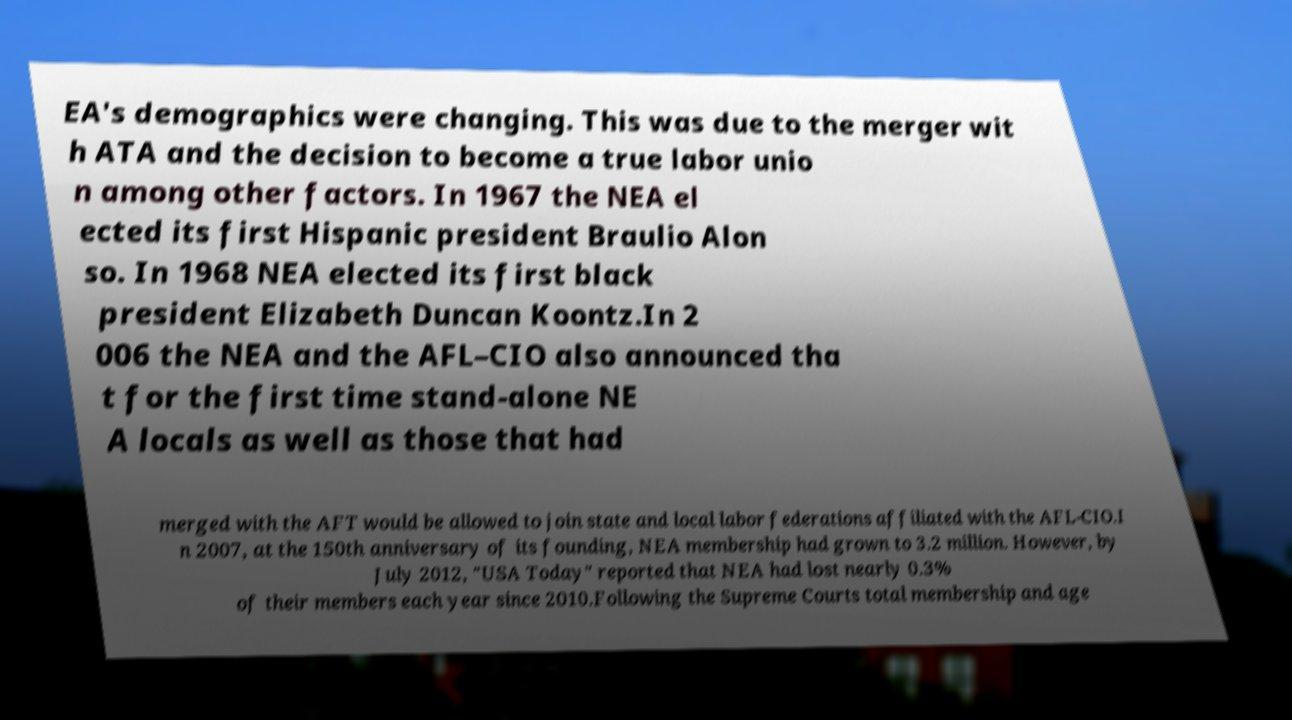Can you read and provide the text displayed in the image?This photo seems to have some interesting text. Can you extract and type it out for me? EA's demographics were changing. This was due to the merger wit h ATA and the decision to become a true labor unio n among other factors. In 1967 the NEA el ected its first Hispanic president Braulio Alon so. In 1968 NEA elected its first black president Elizabeth Duncan Koontz.In 2 006 the NEA and the AFL–CIO also announced tha t for the first time stand-alone NE A locals as well as those that had merged with the AFT would be allowed to join state and local labor federations affiliated with the AFL-CIO.I n 2007, at the 150th anniversary of its founding, NEA membership had grown to 3.2 million. However, by July 2012, "USA Today" reported that NEA had lost nearly 0.3% of their members each year since 2010.Following the Supreme Courts total membership and age 